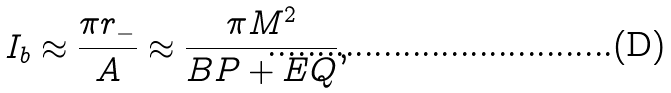<formula> <loc_0><loc_0><loc_500><loc_500>I _ { b } \approx \frac { \pi r _ { - } } { A } \approx \frac { \pi M ^ { 2 } } { B P + E Q } ,</formula> 